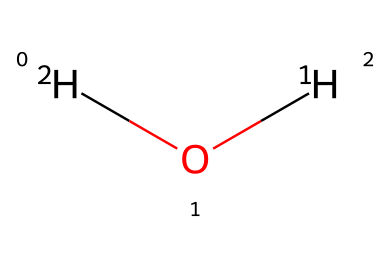What is the molecular formula of this chemical? The chemical consists of two hydrogen atoms and one oxygen atom, which can be represented as H2O.
Answer: H2O How many hydrogen atoms are present in this molecule? The structure indicates two hydrogen atoms (noted as [2H]).
Answer: 2 What type of isotopes does this structure involve? The chemical contains deuterium represented as [2H] and regular hydrogen represented as [1H], classifying it as isotopes of hydrogen.
Answer: isotopes of hydrogen What is the significance of the isotopes in this water sample? The presence of deuterium as opposed to just regular hydrogen may indicate specific contamination sources or environmental influences in the water.
Answer: contamination sources What are the primary elements found in the chemical? The molecule consists solely of hydrogen and oxygen, as denoted in the structure.
Answer: hydrogen, oxygen How does the isotopic composition affect the properties of the water? Isotopic composition can change the physical properties, like boiling and freezing points, and potentially the biological behavior of the water, affecting how it interacts with ecosystems.
Answer: physical properties How many bonds are present in the chemical structure? There are two covalent bonds formed: one between each hydrogen and the oxygen atom in the water molecule.
Answer: 2 